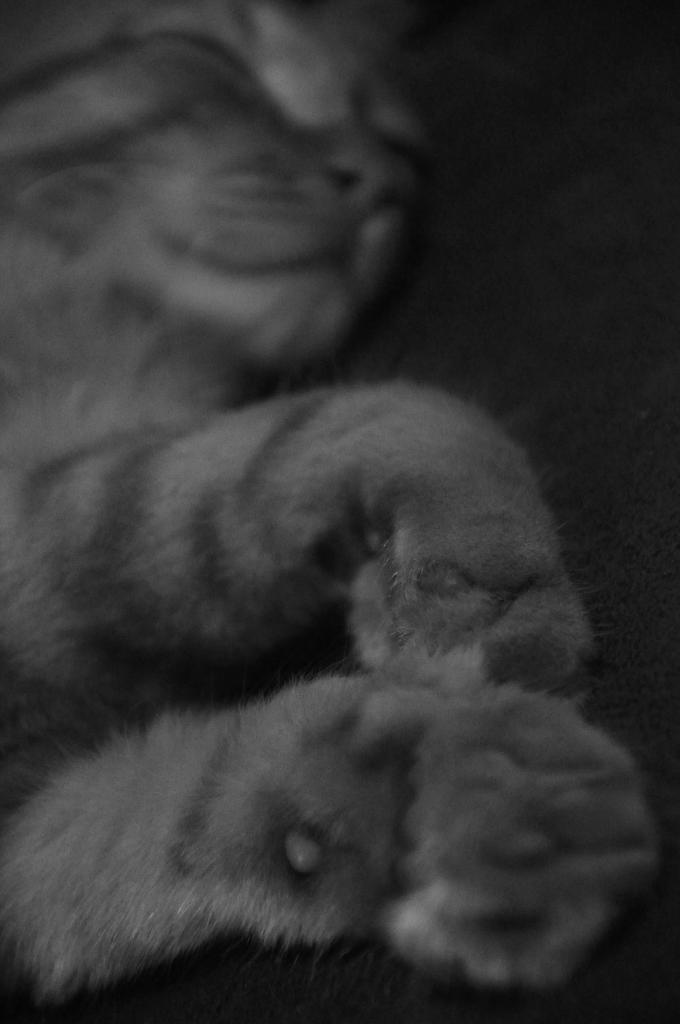What type of animal is present in the image? There is a cat in the image. What is the cat doing in the image? The cat is sleeping. What type of silk material is being used to make the cat's bed in the image? There is no silk material present in the image; the cat is simply sleeping. Where is the nearest hospital to the location of the cat in the image? The provided facts do not give any information about the location of the cat or the image, so it is impossible to determine the nearest hospital. 